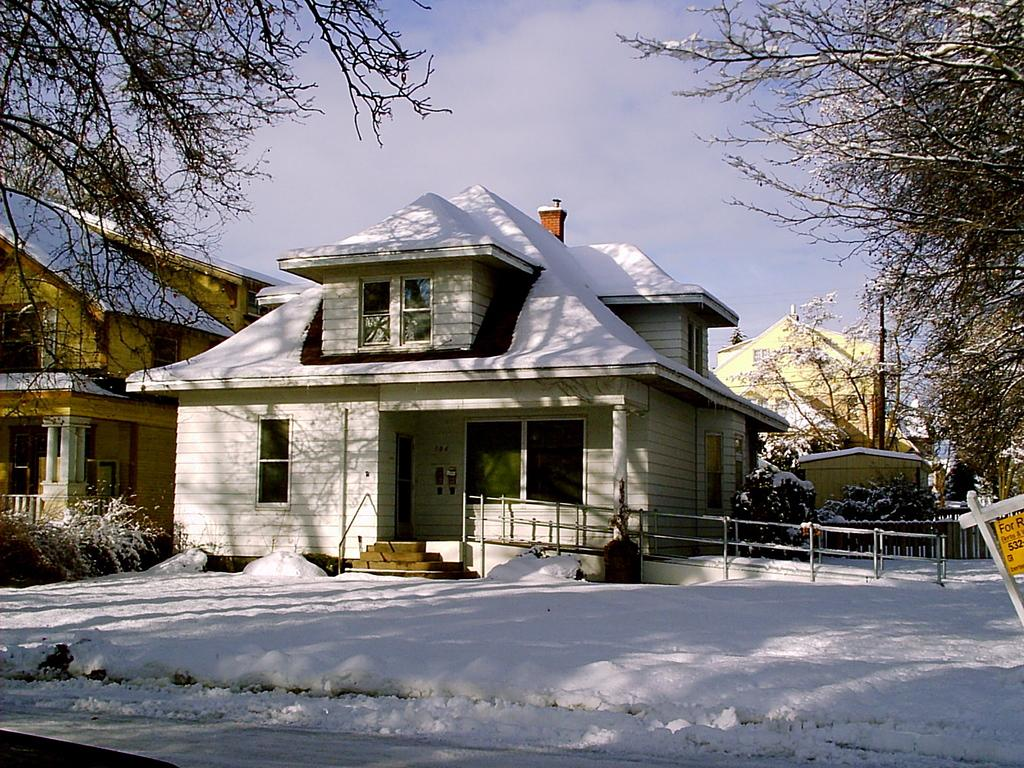What type of structures are present in the image? There are houses in the image. What type of vegetation can be seen in the image? There are trees and plants in the image. What is the weather like in the image? There is snow visible in the image, and the sky is blue and cloudy. What is the purpose of the board with text in the image? The purpose of the board with text is not clear from the image, but it may be a sign or notice. What type of riddle is the brain solving in the image? There is no brain or riddle present in the image. How much payment is required for the services provided in the image? There is no indication of any services or payment in the image. 